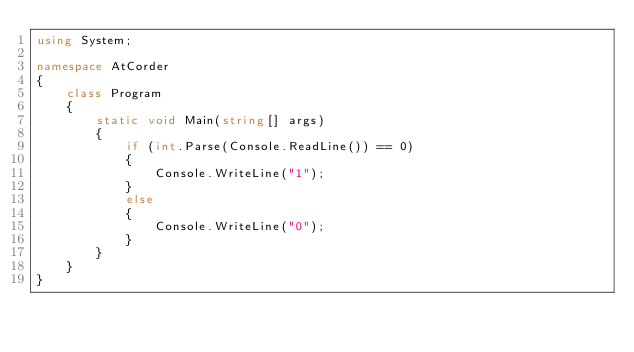<code> <loc_0><loc_0><loc_500><loc_500><_C#_>using System;

namespace AtCorder
{
    class Program
    {
        static void Main(string[] args)
        {
            if (int.Parse(Console.ReadLine()) == 0)
            {
                Console.WriteLine("1");
            }
            else
            {
                Console.WriteLine("0");
            }
        }
    }
}</code> 